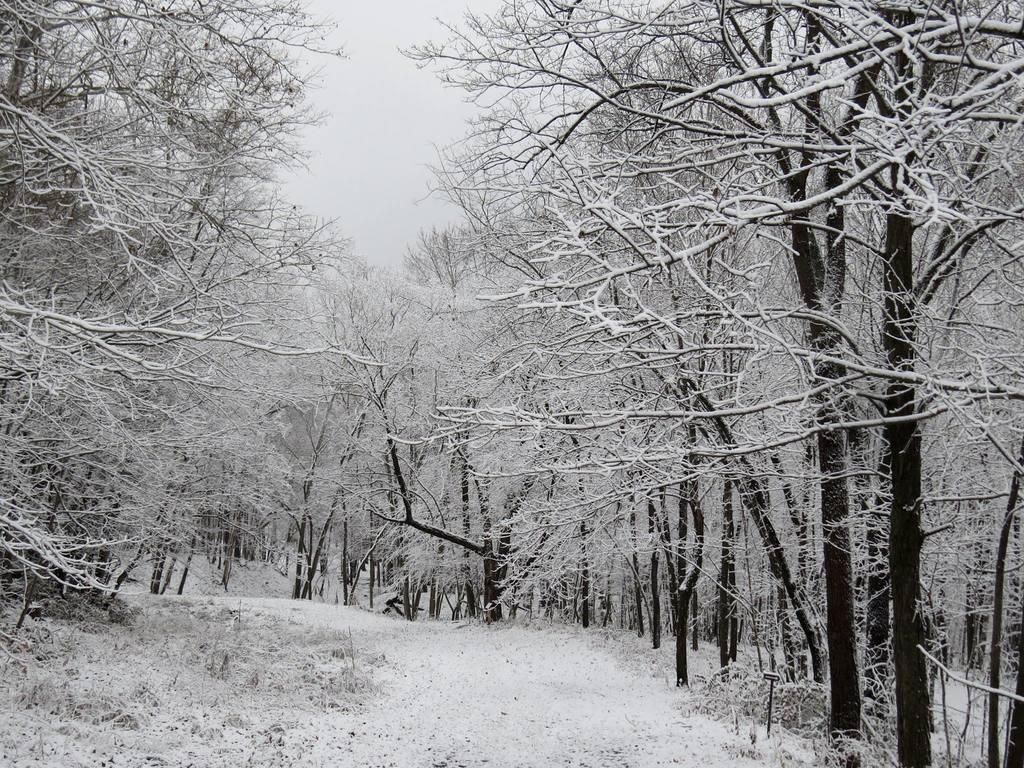In one or two sentences, can you explain what this image depicts? At the bottom of this image, there is a road. On both sides of this road, there are trees. In the background, there are trees and there are clouds in the sky. 